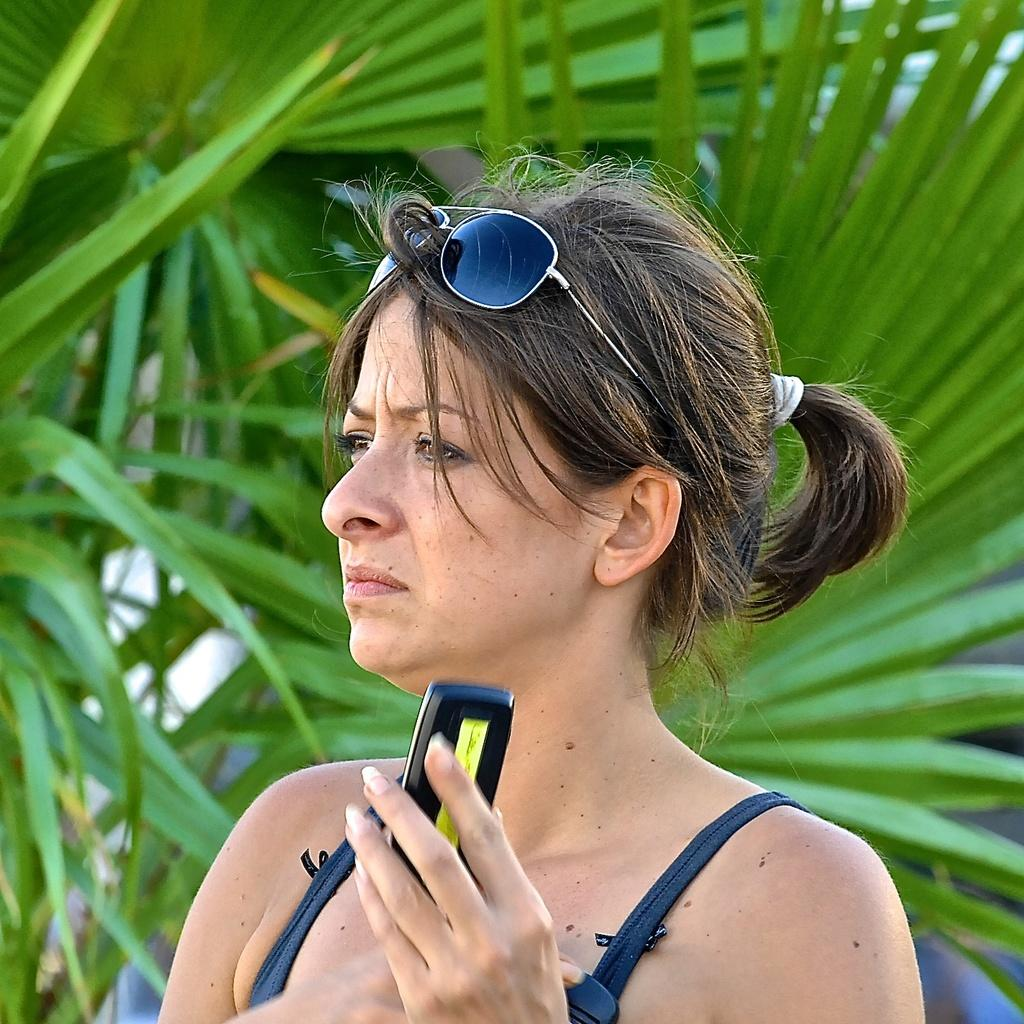Who is present in the image? There is a woman in the image. What is the woman holding in the image? The woman is holding an object. What can be seen in the background of the image? There are trees in the background of the image. What type of oil can be seen dripping from the pan in the image? There is no pan or oil present in the image. 